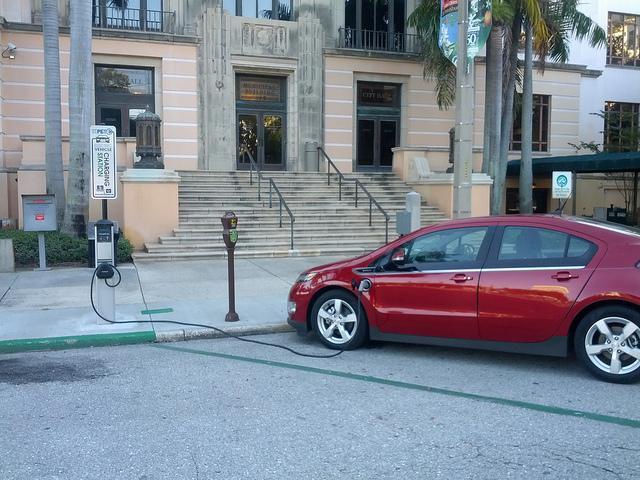How many black cars?
Give a very brief answer. 0. How many tires are visible here?
Give a very brief answer. 2. 